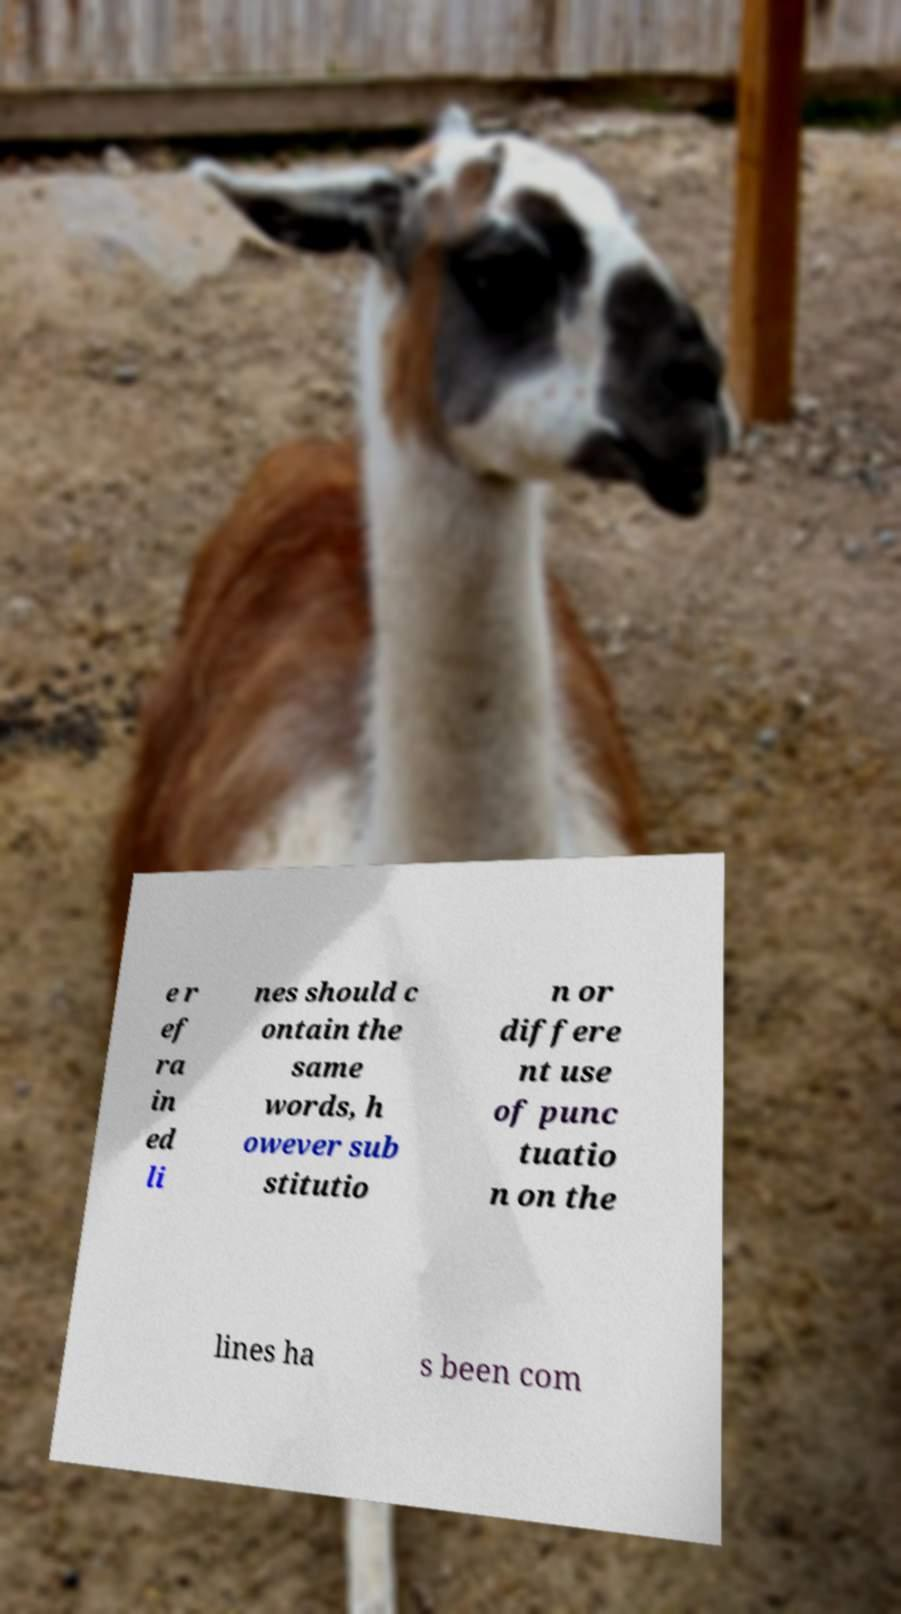What messages or text are displayed in this image? I need them in a readable, typed format. e r ef ra in ed li nes should c ontain the same words, h owever sub stitutio n or differe nt use of punc tuatio n on the lines ha s been com 